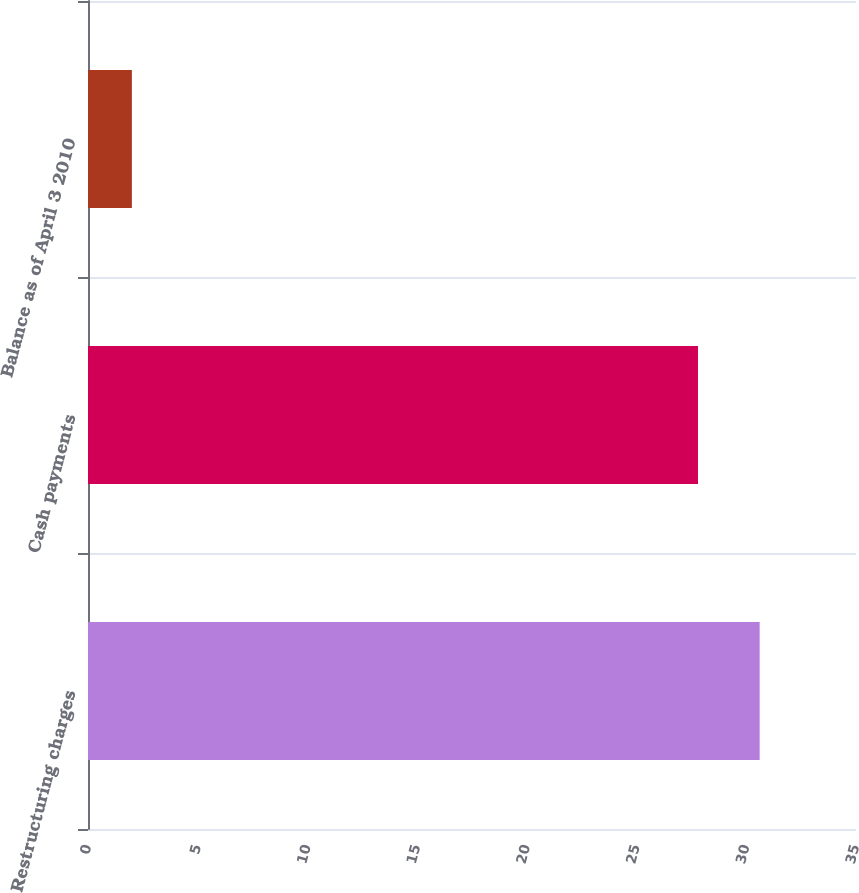Convert chart to OTSL. <chart><loc_0><loc_0><loc_500><loc_500><bar_chart><fcel>Restructuring charges<fcel>Cash payments<fcel>Balance as of April 3 2010<nl><fcel>30.61<fcel>27.8<fcel>2<nl></chart> 